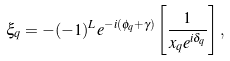Convert formula to latex. <formula><loc_0><loc_0><loc_500><loc_500>\xi _ { q } = - ( - 1 ) ^ { L } e ^ { - i ( \phi _ { q } + \gamma ) } \left [ \frac { 1 } { x _ { q } e ^ { i \delta _ { q } } } \right ] ,</formula> 